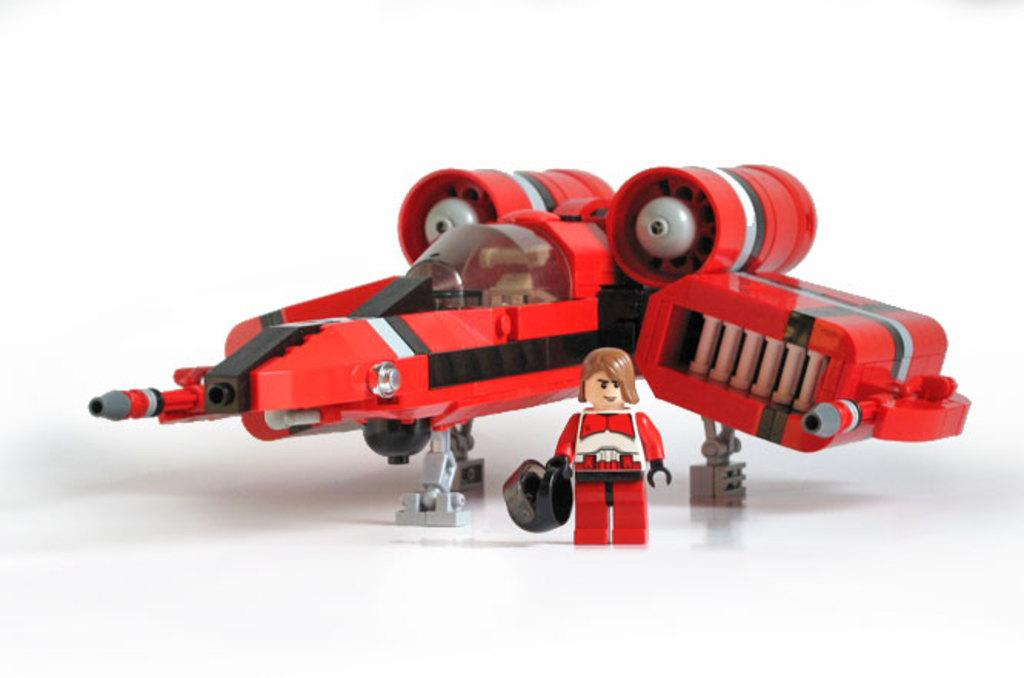What type of toy can be seen in the image? There is a toy aircraft in the image. What other object is present in the image? There is a small doll in the image. What is the doll holding in its hands? The doll is holding a helmet in its hands. What type of lace is being used by the farmer in the image? There is no farmer or lace present in the image. Who is the creator of the toy aircraft in the image? The creator of the toy aircraft is not mentioned in the image or the provided facts. 